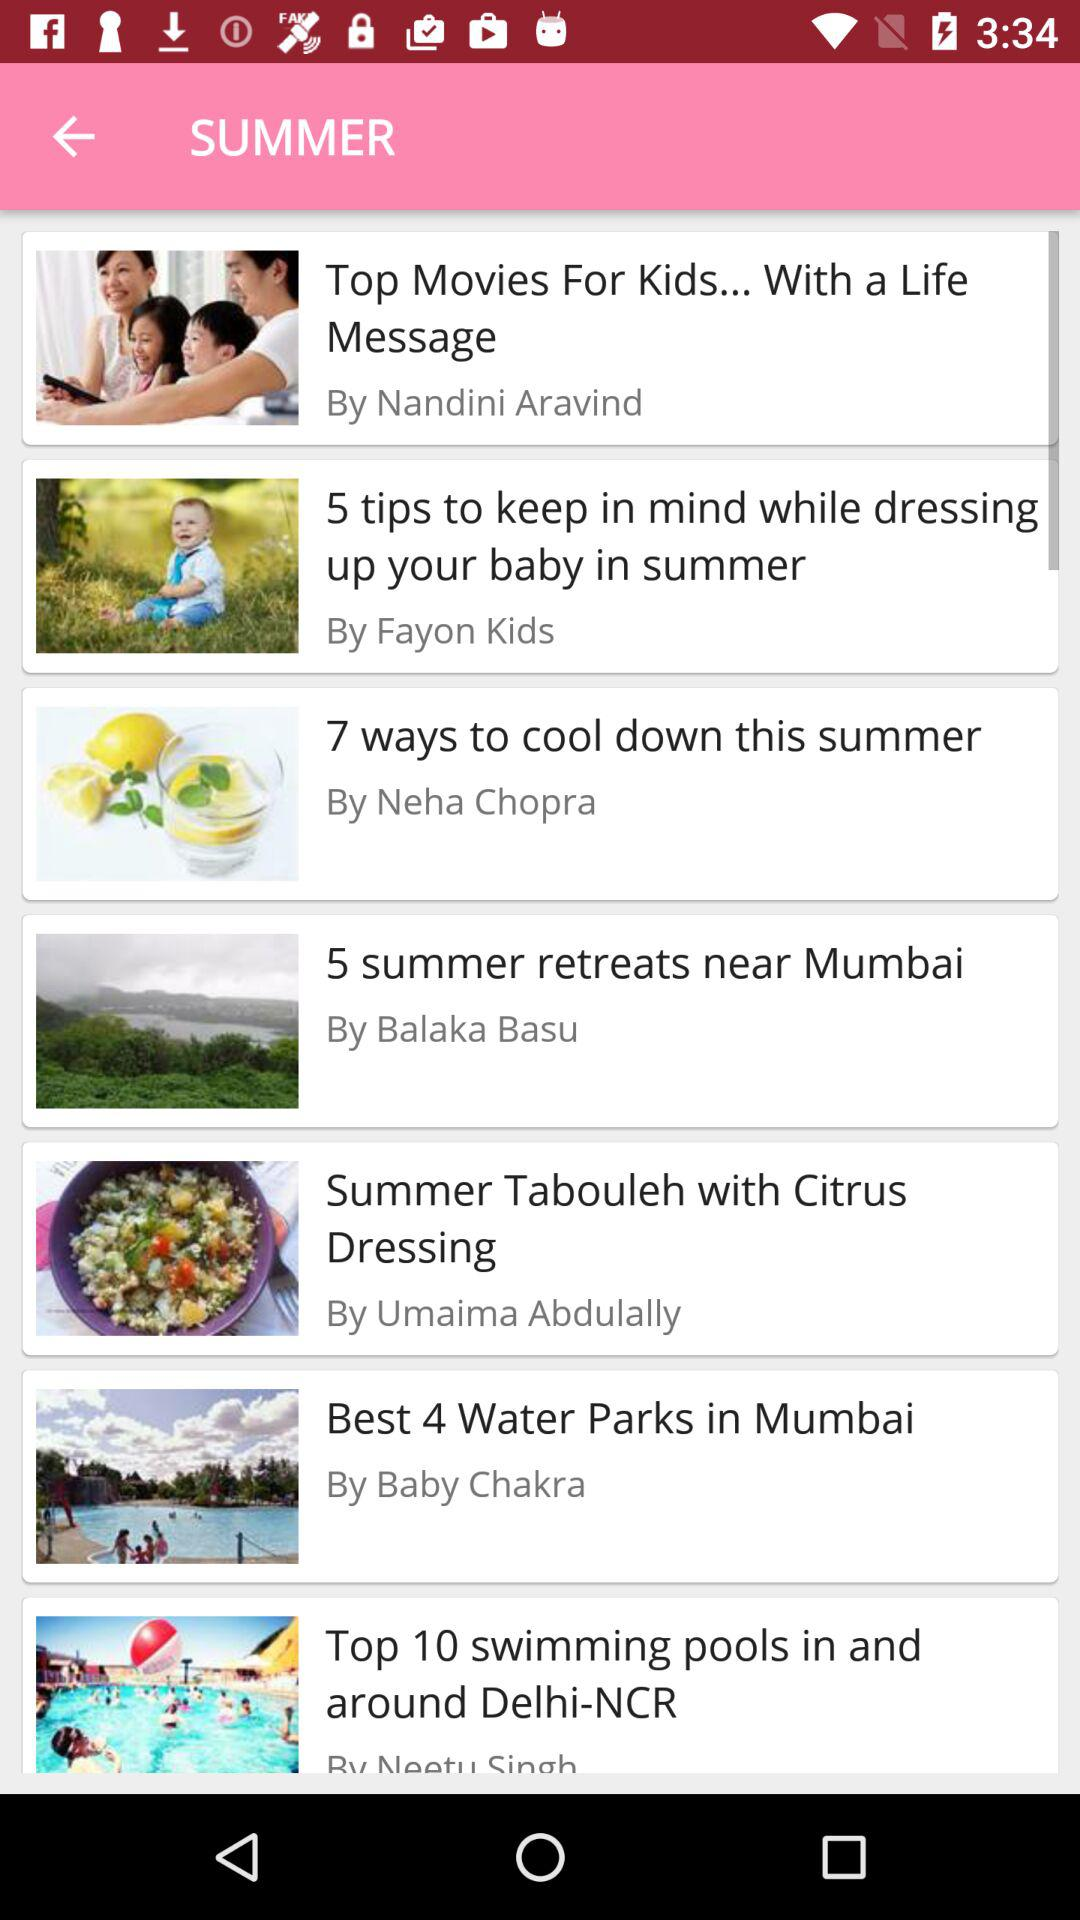How many best water parks are there in Mumbai? In Mumbai, there are 4 best water parks. 